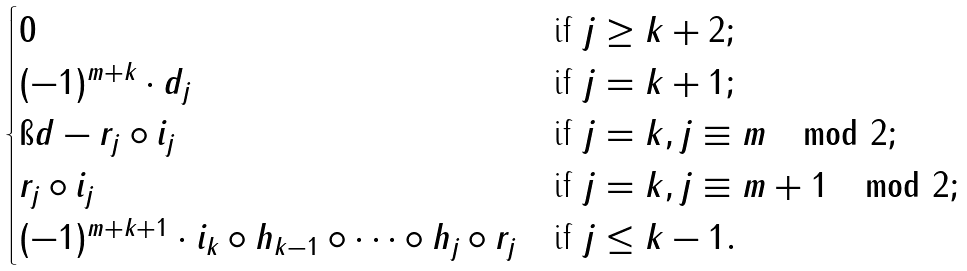Convert formula to latex. <formula><loc_0><loc_0><loc_500><loc_500>\begin{cases} 0 & \text {if } j \geq k + 2 ; \\ ( - 1 ) ^ { m + k } \cdot d _ { j } & \text {if } j = k + 1 ; \\ \i d - r _ { j } \circ i _ { j } & \text {if } j = k , j \equiv m \mod 2 ; \\ r _ { j } \circ i _ { j } & \text {if } j = k , j \equiv m + 1 \mod 2 ; \\ ( - 1 ) ^ { m + k + 1 } \cdot i _ { k } \circ h _ { k - 1 } \circ \dots \circ h _ { j } \circ r _ { j } & \text {if } j \leq k - 1 . \end{cases}</formula> 